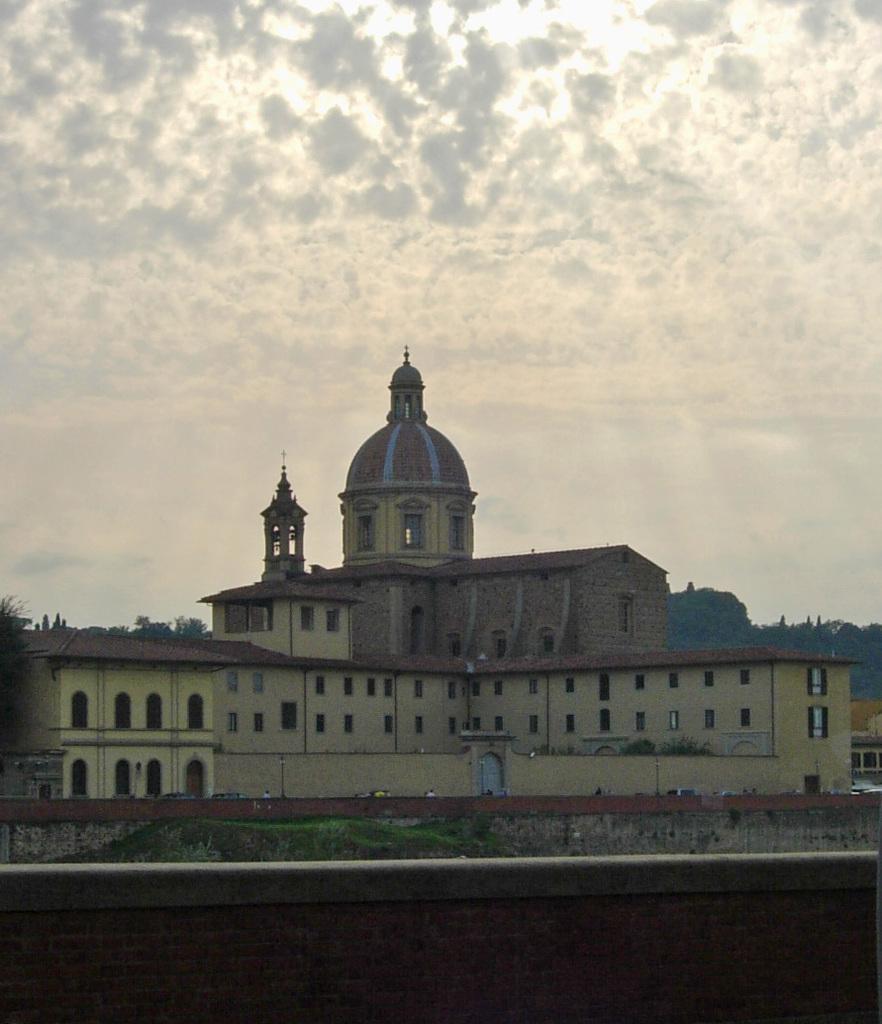How would you summarize this image in a sentence or two? In this image there is a small wall, in the background there is a building, trees and the sky. 